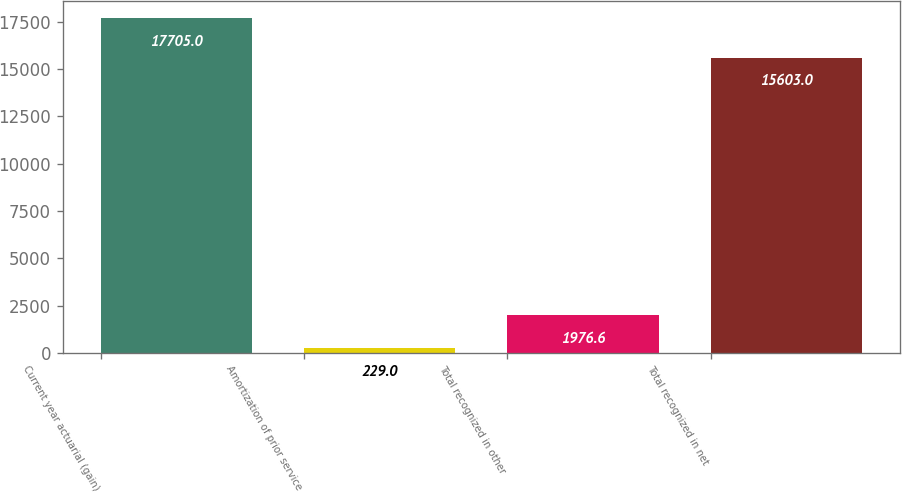<chart> <loc_0><loc_0><loc_500><loc_500><bar_chart><fcel>Current year actuarial (gain)<fcel>Amortization of prior service<fcel>Total recognized in other<fcel>Total recognized in net<nl><fcel>17705<fcel>229<fcel>1976.6<fcel>15603<nl></chart> 